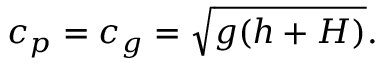<formula> <loc_0><loc_0><loc_500><loc_500>c _ { p } = c _ { g } = { \sqrt { g ( h + H ) } } .</formula> 